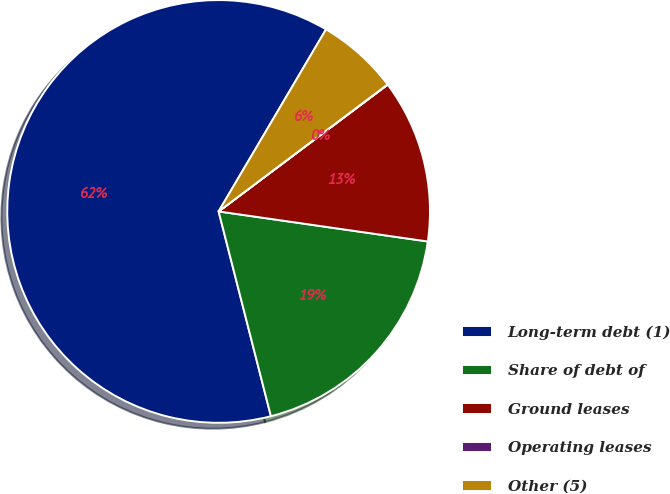Convert chart to OTSL. <chart><loc_0><loc_0><loc_500><loc_500><pie_chart><fcel>Long-term debt (1)<fcel>Share of debt of<fcel>Ground leases<fcel>Operating leases<fcel>Other (5)<nl><fcel>62.46%<fcel>18.75%<fcel>12.51%<fcel>0.02%<fcel>6.26%<nl></chart> 